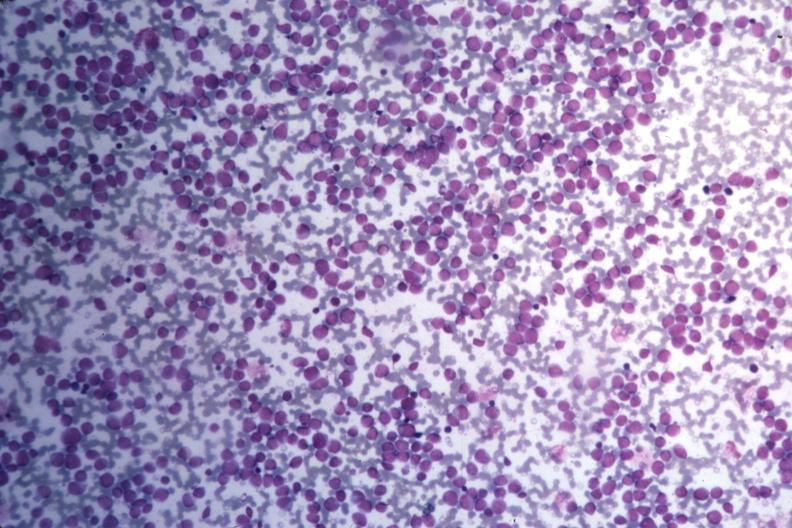what stain many pleomorphic blast cells readily seen?
Answer the question using a single word or phrase. Med wrights 